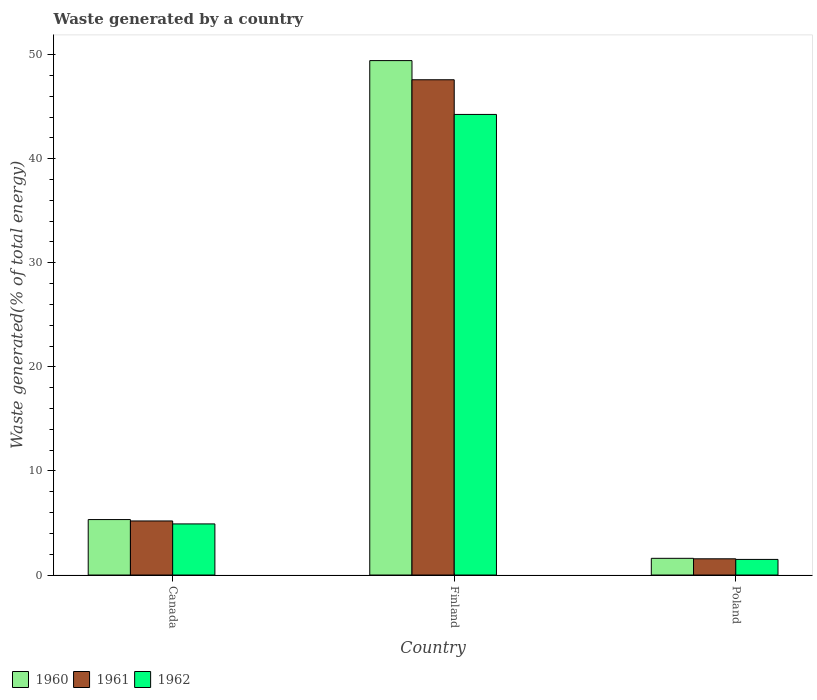How many groups of bars are there?
Keep it short and to the point. 3. How many bars are there on the 3rd tick from the left?
Your answer should be very brief. 3. How many bars are there on the 3rd tick from the right?
Your response must be concise. 3. What is the total waste generated in 1960 in Canada?
Make the answer very short. 5.33. Across all countries, what is the maximum total waste generated in 1962?
Make the answer very short. 44.25. Across all countries, what is the minimum total waste generated in 1960?
Provide a short and direct response. 1.6. In which country was the total waste generated in 1961 maximum?
Your answer should be compact. Finland. What is the total total waste generated in 1960 in the graph?
Your response must be concise. 56.36. What is the difference between the total waste generated in 1961 in Canada and that in Poland?
Ensure brevity in your answer.  3.64. What is the difference between the total waste generated in 1961 in Poland and the total waste generated in 1960 in Canada?
Offer a terse response. -3.77. What is the average total waste generated in 1960 per country?
Provide a short and direct response. 18.79. What is the difference between the total waste generated of/in 1962 and total waste generated of/in 1961 in Finland?
Offer a terse response. -3.33. In how many countries, is the total waste generated in 1962 greater than 44 %?
Offer a terse response. 1. What is the ratio of the total waste generated in 1960 in Finland to that in Poland?
Your answer should be very brief. 30.8. Is the total waste generated in 1960 in Canada less than that in Finland?
Give a very brief answer. Yes. Is the difference between the total waste generated in 1962 in Finland and Poland greater than the difference between the total waste generated in 1961 in Finland and Poland?
Provide a short and direct response. No. What is the difference between the highest and the second highest total waste generated in 1962?
Give a very brief answer. -42.75. What is the difference between the highest and the lowest total waste generated in 1960?
Provide a short and direct response. 47.82. Is the sum of the total waste generated in 1962 in Canada and Poland greater than the maximum total waste generated in 1960 across all countries?
Offer a very short reply. No. What does the 1st bar from the left in Poland represents?
Your answer should be very brief. 1960. How many bars are there?
Give a very brief answer. 9. Are all the bars in the graph horizontal?
Your response must be concise. No. How many countries are there in the graph?
Make the answer very short. 3. Does the graph contain any zero values?
Ensure brevity in your answer.  No. Does the graph contain grids?
Offer a terse response. No. How many legend labels are there?
Make the answer very short. 3. What is the title of the graph?
Your answer should be compact. Waste generated by a country. Does "2005" appear as one of the legend labels in the graph?
Your answer should be compact. No. What is the label or title of the X-axis?
Your answer should be compact. Country. What is the label or title of the Y-axis?
Ensure brevity in your answer.  Waste generated(% of total energy). What is the Waste generated(% of total energy) in 1960 in Canada?
Provide a short and direct response. 5.33. What is the Waste generated(% of total energy) in 1961 in Canada?
Give a very brief answer. 5.19. What is the Waste generated(% of total energy) in 1962 in Canada?
Your answer should be compact. 4.91. What is the Waste generated(% of total energy) of 1960 in Finland?
Offer a terse response. 49.42. What is the Waste generated(% of total energy) of 1961 in Finland?
Your answer should be compact. 47.58. What is the Waste generated(% of total energy) in 1962 in Finland?
Offer a terse response. 44.25. What is the Waste generated(% of total energy) of 1960 in Poland?
Provide a short and direct response. 1.6. What is the Waste generated(% of total energy) of 1961 in Poland?
Your answer should be compact. 1.56. What is the Waste generated(% of total energy) in 1962 in Poland?
Offer a terse response. 1.5. Across all countries, what is the maximum Waste generated(% of total energy) of 1960?
Make the answer very short. 49.42. Across all countries, what is the maximum Waste generated(% of total energy) of 1961?
Provide a short and direct response. 47.58. Across all countries, what is the maximum Waste generated(% of total energy) in 1962?
Make the answer very short. 44.25. Across all countries, what is the minimum Waste generated(% of total energy) in 1960?
Ensure brevity in your answer.  1.6. Across all countries, what is the minimum Waste generated(% of total energy) of 1961?
Make the answer very short. 1.56. Across all countries, what is the minimum Waste generated(% of total energy) of 1962?
Make the answer very short. 1.5. What is the total Waste generated(% of total energy) in 1960 in the graph?
Provide a short and direct response. 56.36. What is the total Waste generated(% of total energy) of 1961 in the graph?
Offer a very short reply. 54.33. What is the total Waste generated(% of total energy) of 1962 in the graph?
Ensure brevity in your answer.  50.66. What is the difference between the Waste generated(% of total energy) of 1960 in Canada and that in Finland?
Provide a succinct answer. -44.1. What is the difference between the Waste generated(% of total energy) of 1961 in Canada and that in Finland?
Offer a terse response. -42.39. What is the difference between the Waste generated(% of total energy) in 1962 in Canada and that in Finland?
Provide a short and direct response. -39.34. What is the difference between the Waste generated(% of total energy) in 1960 in Canada and that in Poland?
Give a very brief answer. 3.72. What is the difference between the Waste generated(% of total energy) of 1961 in Canada and that in Poland?
Your answer should be compact. 3.64. What is the difference between the Waste generated(% of total energy) in 1962 in Canada and that in Poland?
Ensure brevity in your answer.  3.41. What is the difference between the Waste generated(% of total energy) of 1960 in Finland and that in Poland?
Your answer should be compact. 47.82. What is the difference between the Waste generated(% of total energy) of 1961 in Finland and that in Poland?
Give a very brief answer. 46.02. What is the difference between the Waste generated(% of total energy) in 1962 in Finland and that in Poland?
Your response must be concise. 42.75. What is the difference between the Waste generated(% of total energy) of 1960 in Canada and the Waste generated(% of total energy) of 1961 in Finland?
Provide a succinct answer. -42.25. What is the difference between the Waste generated(% of total energy) in 1960 in Canada and the Waste generated(% of total energy) in 1962 in Finland?
Make the answer very short. -38.92. What is the difference between the Waste generated(% of total energy) in 1961 in Canada and the Waste generated(% of total energy) in 1962 in Finland?
Make the answer very short. -39.06. What is the difference between the Waste generated(% of total energy) in 1960 in Canada and the Waste generated(% of total energy) in 1961 in Poland?
Your answer should be compact. 3.77. What is the difference between the Waste generated(% of total energy) of 1960 in Canada and the Waste generated(% of total energy) of 1962 in Poland?
Give a very brief answer. 3.83. What is the difference between the Waste generated(% of total energy) in 1961 in Canada and the Waste generated(% of total energy) in 1962 in Poland?
Provide a short and direct response. 3.7. What is the difference between the Waste generated(% of total energy) of 1960 in Finland and the Waste generated(% of total energy) of 1961 in Poland?
Give a very brief answer. 47.86. What is the difference between the Waste generated(% of total energy) in 1960 in Finland and the Waste generated(% of total energy) in 1962 in Poland?
Your response must be concise. 47.92. What is the difference between the Waste generated(% of total energy) in 1961 in Finland and the Waste generated(% of total energy) in 1962 in Poland?
Provide a succinct answer. 46.08. What is the average Waste generated(% of total energy) of 1960 per country?
Provide a short and direct response. 18.79. What is the average Waste generated(% of total energy) of 1961 per country?
Make the answer very short. 18.11. What is the average Waste generated(% of total energy) of 1962 per country?
Keep it short and to the point. 16.89. What is the difference between the Waste generated(% of total energy) of 1960 and Waste generated(% of total energy) of 1961 in Canada?
Your answer should be compact. 0.13. What is the difference between the Waste generated(% of total energy) of 1960 and Waste generated(% of total energy) of 1962 in Canada?
Keep it short and to the point. 0.42. What is the difference between the Waste generated(% of total energy) in 1961 and Waste generated(% of total energy) in 1962 in Canada?
Keep it short and to the point. 0.28. What is the difference between the Waste generated(% of total energy) in 1960 and Waste generated(% of total energy) in 1961 in Finland?
Make the answer very short. 1.84. What is the difference between the Waste generated(% of total energy) of 1960 and Waste generated(% of total energy) of 1962 in Finland?
Offer a very short reply. 5.17. What is the difference between the Waste generated(% of total energy) of 1961 and Waste generated(% of total energy) of 1962 in Finland?
Provide a succinct answer. 3.33. What is the difference between the Waste generated(% of total energy) of 1960 and Waste generated(% of total energy) of 1961 in Poland?
Your answer should be very brief. 0.05. What is the difference between the Waste generated(% of total energy) in 1960 and Waste generated(% of total energy) in 1962 in Poland?
Ensure brevity in your answer.  0.11. What is the difference between the Waste generated(% of total energy) of 1961 and Waste generated(% of total energy) of 1962 in Poland?
Keep it short and to the point. 0.06. What is the ratio of the Waste generated(% of total energy) of 1960 in Canada to that in Finland?
Keep it short and to the point. 0.11. What is the ratio of the Waste generated(% of total energy) of 1961 in Canada to that in Finland?
Ensure brevity in your answer.  0.11. What is the ratio of the Waste generated(% of total energy) of 1962 in Canada to that in Finland?
Provide a short and direct response. 0.11. What is the ratio of the Waste generated(% of total energy) of 1960 in Canada to that in Poland?
Your response must be concise. 3.32. What is the ratio of the Waste generated(% of total energy) in 1961 in Canada to that in Poland?
Keep it short and to the point. 3.33. What is the ratio of the Waste generated(% of total energy) in 1962 in Canada to that in Poland?
Your answer should be very brief. 3.28. What is the ratio of the Waste generated(% of total energy) in 1960 in Finland to that in Poland?
Make the answer very short. 30.8. What is the ratio of the Waste generated(% of total energy) in 1961 in Finland to that in Poland?
Ensure brevity in your answer.  30.53. What is the ratio of the Waste generated(% of total energy) in 1962 in Finland to that in Poland?
Make the answer very short. 29.52. What is the difference between the highest and the second highest Waste generated(% of total energy) in 1960?
Provide a short and direct response. 44.1. What is the difference between the highest and the second highest Waste generated(% of total energy) in 1961?
Your answer should be very brief. 42.39. What is the difference between the highest and the second highest Waste generated(% of total energy) of 1962?
Make the answer very short. 39.34. What is the difference between the highest and the lowest Waste generated(% of total energy) of 1960?
Your answer should be very brief. 47.82. What is the difference between the highest and the lowest Waste generated(% of total energy) of 1961?
Your response must be concise. 46.02. What is the difference between the highest and the lowest Waste generated(% of total energy) of 1962?
Provide a short and direct response. 42.75. 